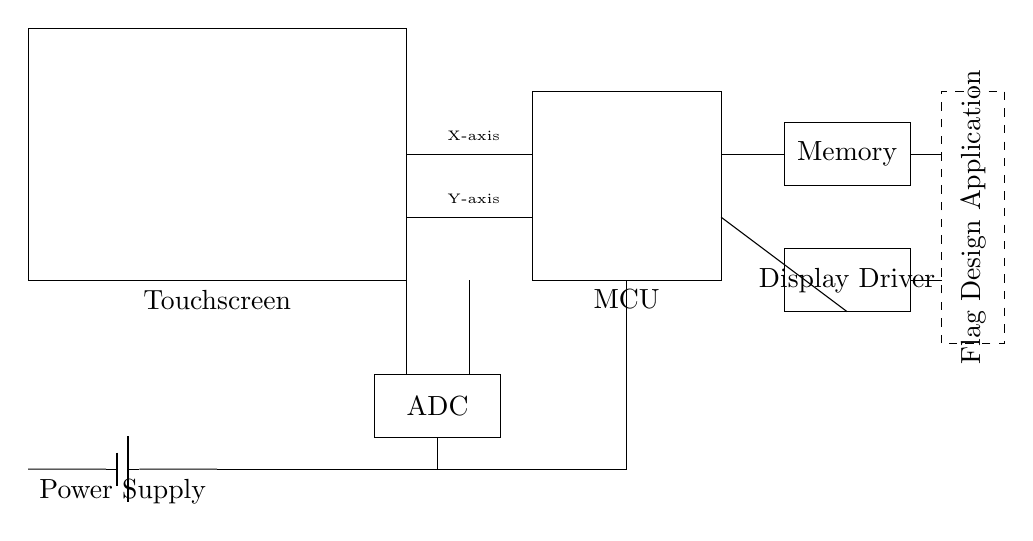What component displays user interactions in this circuit? The touchscreen is the component responsible for displaying user interactions as it simulates touch input and graphical output.
Answer: Touchscreen What is the role of the microcontroller? The microcontroller (MCU) processes the inputs from the touchscreen and controls the overall operation of the circuit, coordinating communication between components.
Answer: MCU How many axes does the touchscreen support for user input? The touchscreen supports two axes: X-axis and Y-axis, which allow it to detect touch coordinates in a two-dimensional plane.
Answer: Two What is connected to the power supply? The power supply is connected to the touchscreen, microcontroller, and ADC, providing necessary electrical energy to these components to function.
Answer: Touchscreen, MCU, ADC How does the ADC interact with the microcontroller? The ADC converts the analog signals from the touchscreen into digital data that the microcontroller can process, facilitating the reading of user inputs.
Answer: Conversion of signals What functions does the memory component serve in this circuit? The memory component stores application data and configuration settings for the flag design application, allowing the microcontroller to access data efficiently during operation.
Answer: Stores data What application is indicated in the circuit diagram? The circuit diagram specifies a flag design application, which presumably involves creating and modifying flag graphics based on user interaction with the touchscreen.
Answer: Flag Design Application 